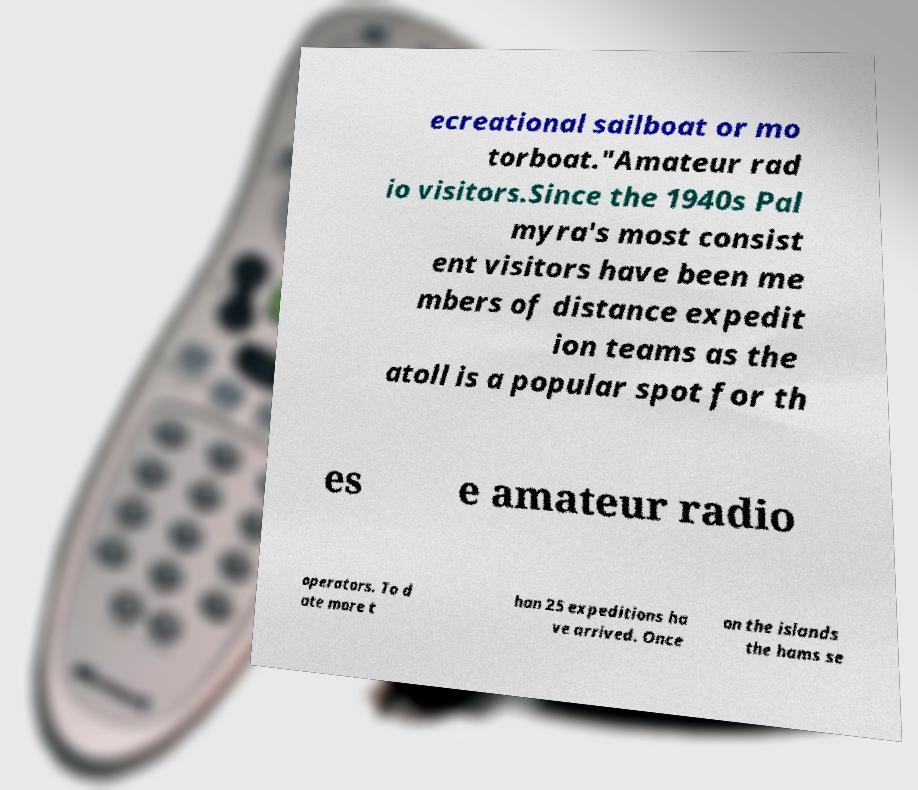Can you read and provide the text displayed in the image?This photo seems to have some interesting text. Can you extract and type it out for me? ecreational sailboat or mo torboat."Amateur rad io visitors.Since the 1940s Pal myra's most consist ent visitors have been me mbers of distance expedit ion teams as the atoll is a popular spot for th es e amateur radio operators. To d ate more t han 25 expeditions ha ve arrived. Once on the islands the hams se 